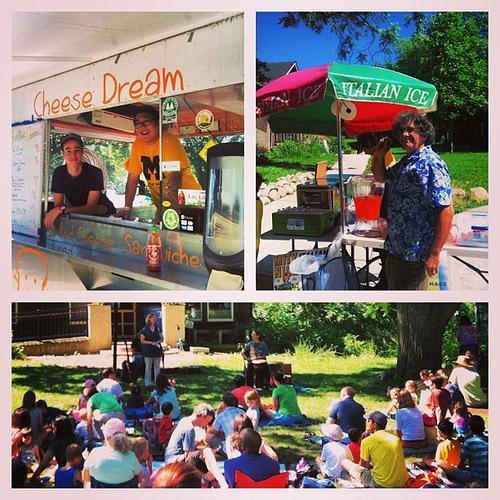How many people are shown standing?
Give a very brief answer. 5. How many food vendors are there?
Give a very brief answer. 2. 